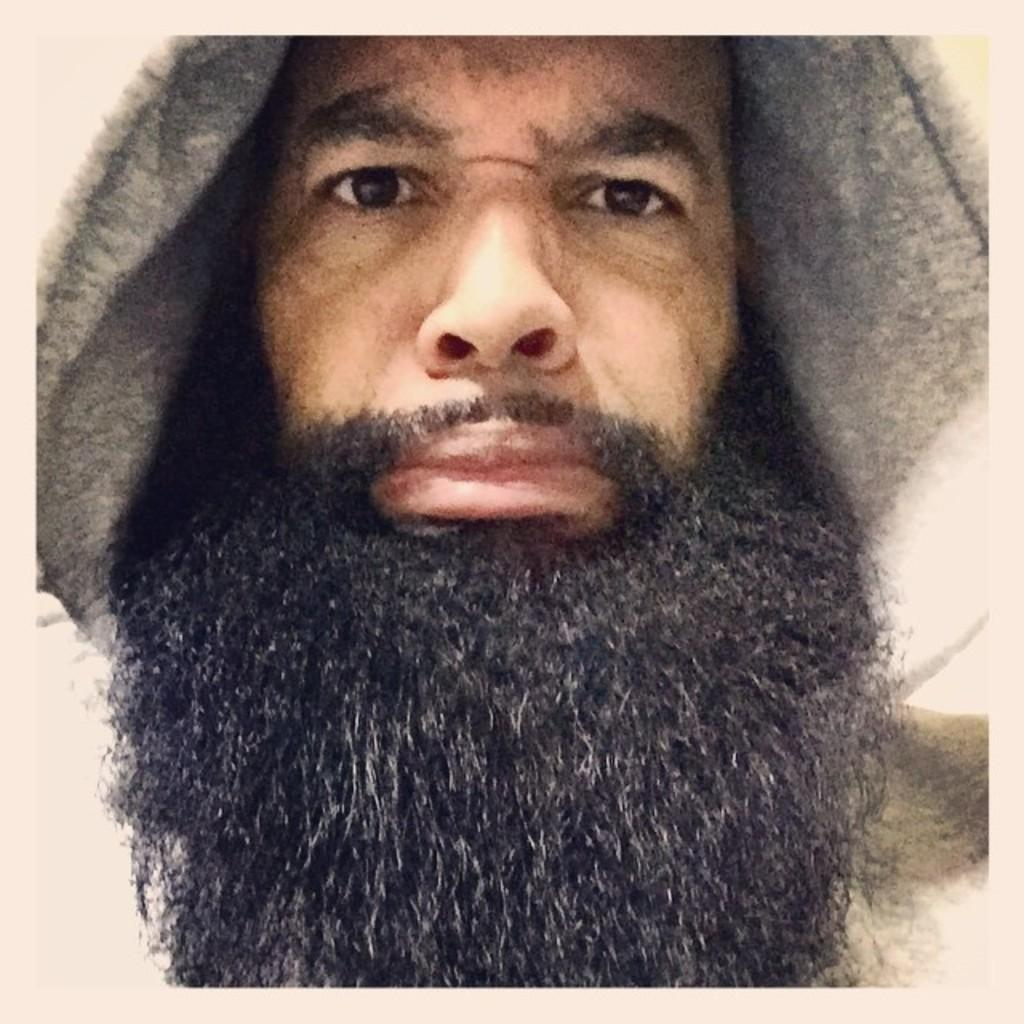Who or what is the main subject in the image? There is a person in the image. What is the person wearing? The person is wearing a grey-colored dress. Can you describe any facial features of the person? The person has a long beard, which is black in color. What type of straw is the person holding in the image? There is no straw present in the image. 